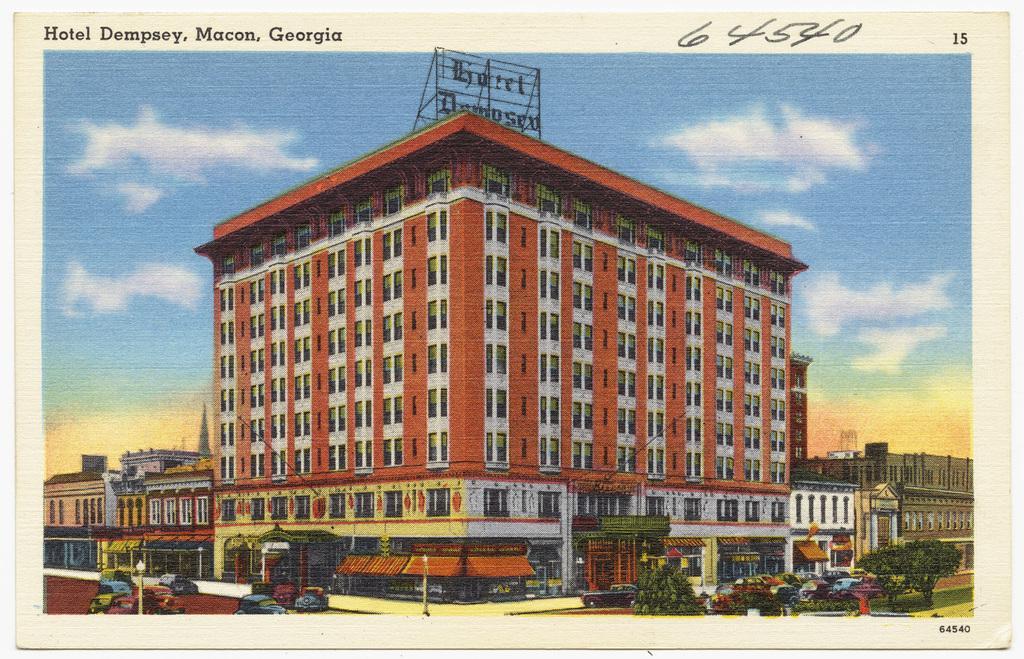How would you summarize this image in a sentence or two? In this image, we can see some buildings, cars and trees. There is a text in the top left of the image. There is a sky at the top of the image. 